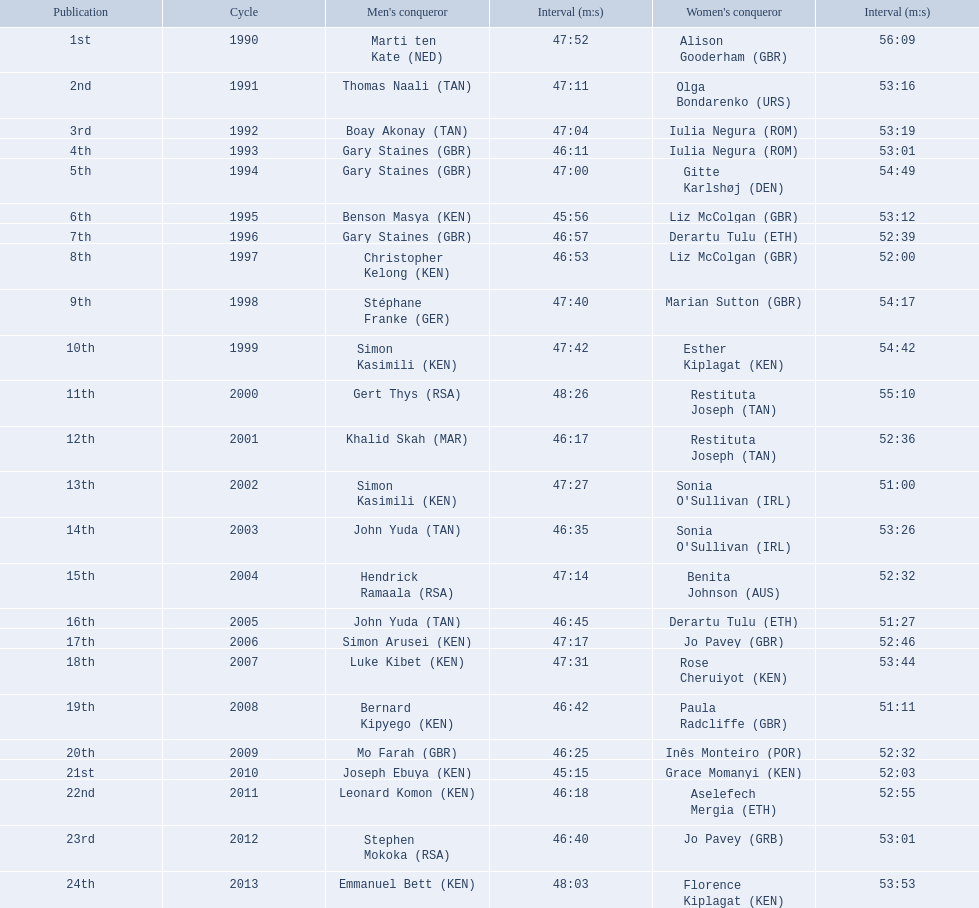What are the names of each male winner? Marti ten Kate (NED), Thomas Naali (TAN), Boay Akonay (TAN), Gary Staines (GBR), Gary Staines (GBR), Benson Masya (KEN), Gary Staines (GBR), Christopher Kelong (KEN), Stéphane Franke (GER), Simon Kasimili (KEN), Gert Thys (RSA), Khalid Skah (MAR), Simon Kasimili (KEN), John Yuda (TAN), Hendrick Ramaala (RSA), John Yuda (TAN), Simon Arusei (KEN), Luke Kibet (KEN), Bernard Kipyego (KEN), Mo Farah (GBR), Joseph Ebuya (KEN), Leonard Komon (KEN), Stephen Mokoka (RSA), Emmanuel Bett (KEN). When did they race? 1990, 1991, 1992, 1993, 1994, 1995, 1996, 1997, 1998, 1999, 2000, 2001, 2002, 2003, 2004, 2005, 2006, 2007, 2008, 2009, 2010, 2011, 2012, 2013. And what were their times? 47:52, 47:11, 47:04, 46:11, 47:00, 45:56, 46:57, 46:53, 47:40, 47:42, 48:26, 46:17, 47:27, 46:35, 47:14, 46:45, 47:17, 47:31, 46:42, 46:25, 45:15, 46:18, 46:40, 48:03. Of those times, which athlete had the fastest time? Joseph Ebuya (KEN). 